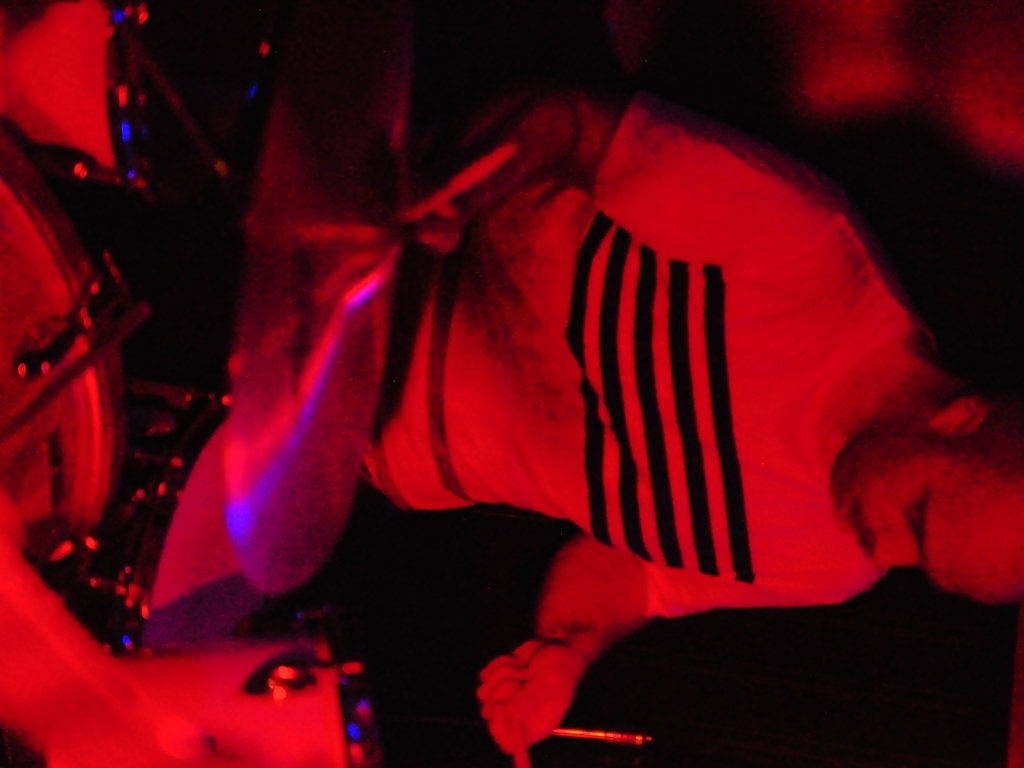Is the main subject of the image blurry?
 Yes 